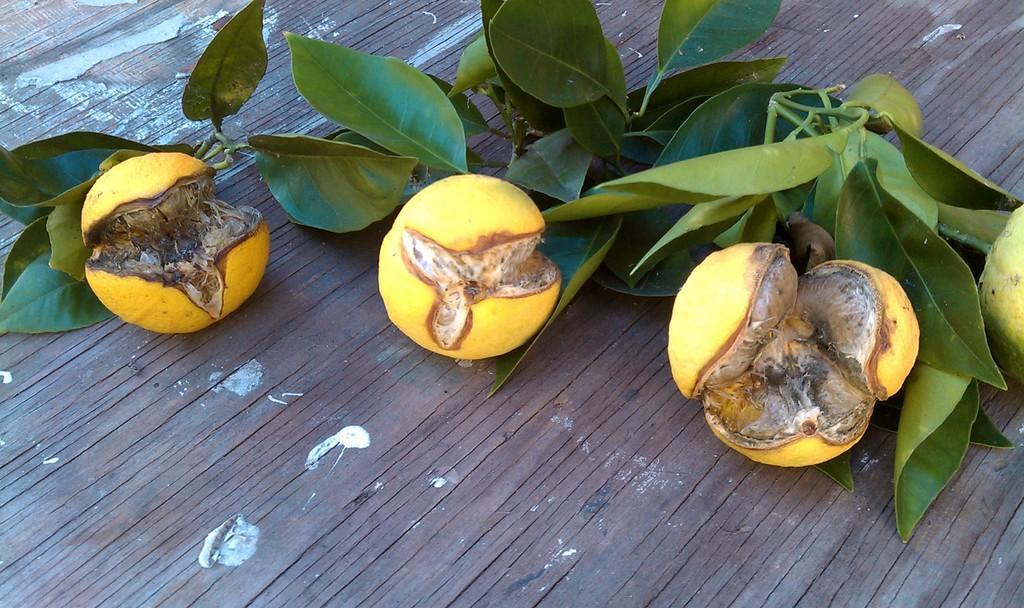How would you summarize this image in a sentence or two? In this image we can see fruits and some leaves on the wood. 